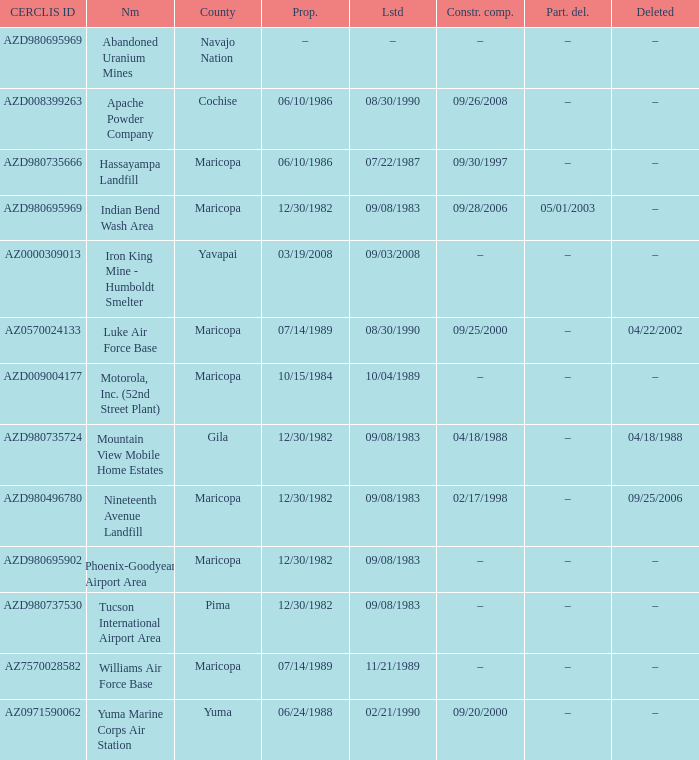When was the site partially deleted when the cerclis id is az7570028582? –. 